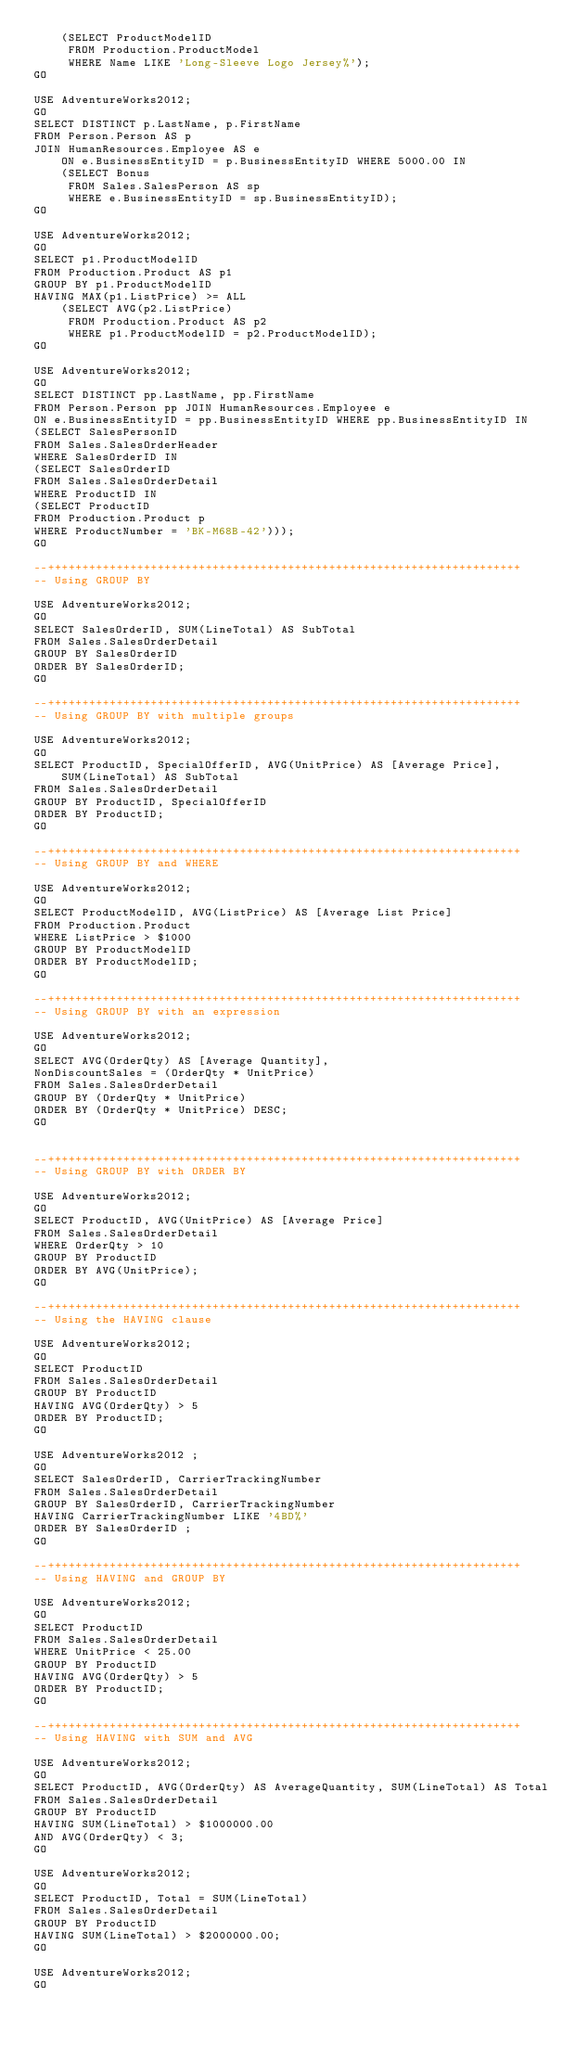<code> <loc_0><loc_0><loc_500><loc_500><_SQL_>    (SELECT ProductModelID 
     FROM Production.ProductModel
     WHERE Name LIKE 'Long-Sleeve Logo Jersey%');
GO

USE AdventureWorks2012;
GO
SELECT DISTINCT p.LastName, p.FirstName 
FROM Person.Person AS p 
JOIN HumanResources.Employee AS e
    ON e.BusinessEntityID = p.BusinessEntityID WHERE 5000.00 IN
    (SELECT Bonus
     FROM Sales.SalesPerson AS sp
     WHERE e.BusinessEntityID = sp.BusinessEntityID);
GO

USE AdventureWorks2012;
GO
SELECT p1.ProductModelID
FROM Production.Product AS p1
GROUP BY p1.ProductModelID
HAVING MAX(p1.ListPrice) >= ALL
    (SELECT AVG(p2.ListPrice)
     FROM Production.Product AS p2
     WHERE p1.ProductModelID = p2.ProductModelID);
GO

USE AdventureWorks2012;
GO
SELECT DISTINCT pp.LastName, pp.FirstName 
FROM Person.Person pp JOIN HumanResources.Employee e
ON e.BusinessEntityID = pp.BusinessEntityID WHERE pp.BusinessEntityID IN 
(SELECT SalesPersonID 
FROM Sales.SalesOrderHeader
WHERE SalesOrderID IN 
(SELECT SalesOrderID 
FROM Sales.SalesOrderDetail
WHERE ProductID IN 
(SELECT ProductID 
FROM Production.Product p 
WHERE ProductNumber = 'BK-M68B-42')));
GO

--+++++++++++++++++++++++++++++++++++++++++++++++++++++++++++++++++++++
-- Using GROUP BY

USE AdventureWorks2012;
GO
SELECT SalesOrderID, SUM(LineTotal) AS SubTotal
FROM Sales.SalesOrderDetail
GROUP BY SalesOrderID
ORDER BY SalesOrderID;
GO

--+++++++++++++++++++++++++++++++++++++++++++++++++++++++++++++++++++++
-- Using GROUP BY with multiple groups

USE AdventureWorks2012;
GO
SELECT ProductID, SpecialOfferID, AVG(UnitPrice) AS [Average Price], 
    SUM(LineTotal) AS SubTotal
FROM Sales.SalesOrderDetail
GROUP BY ProductID, SpecialOfferID
ORDER BY ProductID;
GO

--+++++++++++++++++++++++++++++++++++++++++++++++++++++++++++++++++++++
-- Using GROUP BY and WHERE

USE AdventureWorks2012;
GO
SELECT ProductModelID, AVG(ListPrice) AS [Average List Price]
FROM Production.Product
WHERE ListPrice > $1000
GROUP BY ProductModelID
ORDER BY ProductModelID;
GO

--+++++++++++++++++++++++++++++++++++++++++++++++++++++++++++++++++++++
-- Using GROUP BY with an expression

USE AdventureWorks2012;
GO
SELECT AVG(OrderQty) AS [Average Quantity], 
NonDiscountSales = (OrderQty * UnitPrice)
FROM Sales.SalesOrderDetail
GROUP BY (OrderQty * UnitPrice)
ORDER BY (OrderQty * UnitPrice) DESC;
GO


--+++++++++++++++++++++++++++++++++++++++++++++++++++++++++++++++++++++
-- Using GROUP BY with ORDER BY

USE AdventureWorks2012;
GO
SELECT ProductID, AVG(UnitPrice) AS [Average Price]
FROM Sales.SalesOrderDetail
WHERE OrderQty > 10
GROUP BY ProductID
ORDER BY AVG(UnitPrice);
GO

--+++++++++++++++++++++++++++++++++++++++++++++++++++++++++++++++++++++
-- Using the HAVING clause

USE AdventureWorks2012;
GO
SELECT ProductID 
FROM Sales.SalesOrderDetail
GROUP BY ProductID
HAVING AVG(OrderQty) > 5
ORDER BY ProductID;
GO

USE AdventureWorks2012 ;
GO
SELECT SalesOrderID, CarrierTrackingNumber 
FROM Sales.SalesOrderDetail
GROUP BY SalesOrderID, CarrierTrackingNumber
HAVING CarrierTrackingNumber LIKE '4BD%'
ORDER BY SalesOrderID ;
GO

--+++++++++++++++++++++++++++++++++++++++++++++++++++++++++++++++++++++
-- Using HAVING and GROUP BY

USE AdventureWorks2012;
GO
SELECT ProductID 
FROM Sales.SalesOrderDetail
WHERE UnitPrice < 25.00
GROUP BY ProductID
HAVING AVG(OrderQty) > 5
ORDER BY ProductID;
GO

--+++++++++++++++++++++++++++++++++++++++++++++++++++++++++++++++++++++
-- Using HAVING with SUM and AVG

USE AdventureWorks2012;
GO
SELECT ProductID, AVG(OrderQty) AS AverageQuantity, SUM(LineTotal) AS Total
FROM Sales.SalesOrderDetail
GROUP BY ProductID
HAVING SUM(LineTotal) > $1000000.00
AND AVG(OrderQty) < 3;
GO

USE AdventureWorks2012;
GO
SELECT ProductID, Total = SUM(LineTotal)
FROM Sales.SalesOrderDetail
GROUP BY ProductID
HAVING SUM(LineTotal) > $2000000.00;
GO

USE AdventureWorks2012;
GO</code> 